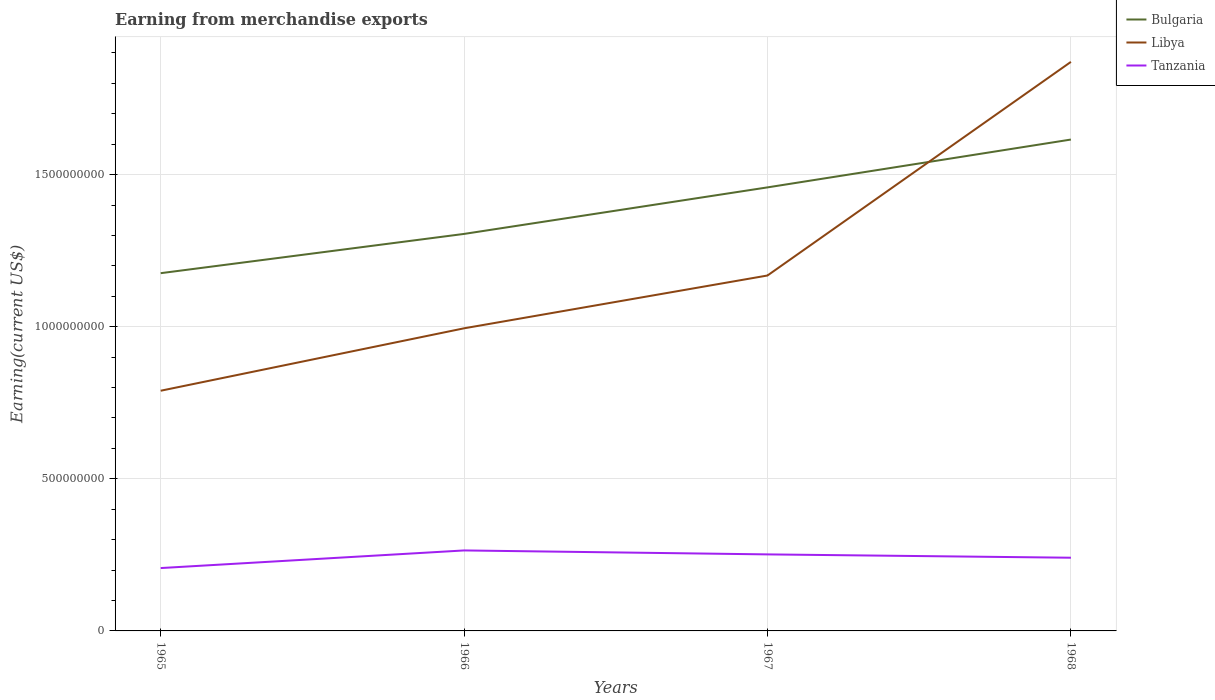Does the line corresponding to Bulgaria intersect with the line corresponding to Libya?
Provide a short and direct response. Yes. Across all years, what is the maximum amount earned from merchandise exports in Bulgaria?
Offer a terse response. 1.18e+09. In which year was the amount earned from merchandise exports in Tanzania maximum?
Make the answer very short. 1965. What is the total amount earned from merchandise exports in Libya in the graph?
Ensure brevity in your answer.  -1.74e+08. What is the difference between the highest and the second highest amount earned from merchandise exports in Bulgaria?
Give a very brief answer. 4.39e+08. How many years are there in the graph?
Provide a succinct answer. 4. Are the values on the major ticks of Y-axis written in scientific E-notation?
Ensure brevity in your answer.  No. Does the graph contain any zero values?
Keep it short and to the point. No. Where does the legend appear in the graph?
Keep it short and to the point. Top right. How many legend labels are there?
Offer a terse response. 3. What is the title of the graph?
Your answer should be compact. Earning from merchandise exports. Does "Vietnam" appear as one of the legend labels in the graph?
Offer a very short reply. No. What is the label or title of the Y-axis?
Provide a succinct answer. Earning(current US$). What is the Earning(current US$) in Bulgaria in 1965?
Make the answer very short. 1.18e+09. What is the Earning(current US$) of Libya in 1965?
Keep it short and to the point. 7.90e+08. What is the Earning(current US$) in Tanzania in 1965?
Give a very brief answer. 2.07e+08. What is the Earning(current US$) in Bulgaria in 1966?
Give a very brief answer. 1.31e+09. What is the Earning(current US$) in Libya in 1966?
Your response must be concise. 9.95e+08. What is the Earning(current US$) of Tanzania in 1966?
Keep it short and to the point. 2.65e+08. What is the Earning(current US$) in Bulgaria in 1967?
Your response must be concise. 1.46e+09. What is the Earning(current US$) of Libya in 1967?
Give a very brief answer. 1.17e+09. What is the Earning(current US$) of Tanzania in 1967?
Provide a short and direct response. 2.52e+08. What is the Earning(current US$) of Bulgaria in 1968?
Ensure brevity in your answer.  1.62e+09. What is the Earning(current US$) in Libya in 1968?
Provide a short and direct response. 1.87e+09. What is the Earning(current US$) of Tanzania in 1968?
Your answer should be very brief. 2.41e+08. Across all years, what is the maximum Earning(current US$) of Bulgaria?
Keep it short and to the point. 1.62e+09. Across all years, what is the maximum Earning(current US$) in Libya?
Your answer should be compact. 1.87e+09. Across all years, what is the maximum Earning(current US$) in Tanzania?
Keep it short and to the point. 2.65e+08. Across all years, what is the minimum Earning(current US$) in Bulgaria?
Your answer should be compact. 1.18e+09. Across all years, what is the minimum Earning(current US$) in Libya?
Your answer should be very brief. 7.90e+08. Across all years, what is the minimum Earning(current US$) in Tanzania?
Keep it short and to the point. 2.07e+08. What is the total Earning(current US$) in Bulgaria in the graph?
Offer a very short reply. 5.55e+09. What is the total Earning(current US$) in Libya in the graph?
Make the answer very short. 4.82e+09. What is the total Earning(current US$) in Tanzania in the graph?
Your response must be concise. 9.63e+08. What is the difference between the Earning(current US$) in Bulgaria in 1965 and that in 1966?
Offer a terse response. -1.29e+08. What is the difference between the Earning(current US$) of Libya in 1965 and that in 1966?
Provide a short and direct response. -2.05e+08. What is the difference between the Earning(current US$) in Tanzania in 1965 and that in 1966?
Provide a short and direct response. -5.80e+07. What is the difference between the Earning(current US$) of Bulgaria in 1965 and that in 1967?
Make the answer very short. -2.82e+08. What is the difference between the Earning(current US$) in Libya in 1965 and that in 1967?
Offer a terse response. -3.79e+08. What is the difference between the Earning(current US$) in Tanzania in 1965 and that in 1967?
Provide a succinct answer. -4.49e+07. What is the difference between the Earning(current US$) in Bulgaria in 1965 and that in 1968?
Your answer should be very brief. -4.39e+08. What is the difference between the Earning(current US$) in Libya in 1965 and that in 1968?
Give a very brief answer. -1.08e+09. What is the difference between the Earning(current US$) in Tanzania in 1965 and that in 1968?
Your response must be concise. -3.40e+07. What is the difference between the Earning(current US$) in Bulgaria in 1966 and that in 1967?
Your response must be concise. -1.53e+08. What is the difference between the Earning(current US$) in Libya in 1966 and that in 1967?
Keep it short and to the point. -1.74e+08. What is the difference between the Earning(current US$) of Tanzania in 1966 and that in 1967?
Offer a terse response. 1.30e+07. What is the difference between the Earning(current US$) of Bulgaria in 1966 and that in 1968?
Offer a terse response. -3.10e+08. What is the difference between the Earning(current US$) of Libya in 1966 and that in 1968?
Offer a very short reply. -8.76e+08. What is the difference between the Earning(current US$) in Tanzania in 1966 and that in 1968?
Provide a short and direct response. 2.39e+07. What is the difference between the Earning(current US$) of Bulgaria in 1967 and that in 1968?
Provide a short and direct response. -1.57e+08. What is the difference between the Earning(current US$) in Libya in 1967 and that in 1968?
Your response must be concise. -7.02e+08. What is the difference between the Earning(current US$) of Tanzania in 1967 and that in 1968?
Your response must be concise. 1.09e+07. What is the difference between the Earning(current US$) of Bulgaria in 1965 and the Earning(current US$) of Libya in 1966?
Your answer should be very brief. 1.81e+08. What is the difference between the Earning(current US$) of Bulgaria in 1965 and the Earning(current US$) of Tanzania in 1966?
Give a very brief answer. 9.11e+08. What is the difference between the Earning(current US$) in Libya in 1965 and the Earning(current US$) in Tanzania in 1966?
Your response must be concise. 5.25e+08. What is the difference between the Earning(current US$) in Bulgaria in 1965 and the Earning(current US$) in Libya in 1967?
Provide a short and direct response. 7.63e+06. What is the difference between the Earning(current US$) of Bulgaria in 1965 and the Earning(current US$) of Tanzania in 1967?
Make the answer very short. 9.25e+08. What is the difference between the Earning(current US$) of Libya in 1965 and the Earning(current US$) of Tanzania in 1967?
Offer a terse response. 5.38e+08. What is the difference between the Earning(current US$) of Bulgaria in 1965 and the Earning(current US$) of Libya in 1968?
Make the answer very short. -6.95e+08. What is the difference between the Earning(current US$) in Bulgaria in 1965 and the Earning(current US$) in Tanzania in 1968?
Offer a terse response. 9.35e+08. What is the difference between the Earning(current US$) in Libya in 1965 and the Earning(current US$) in Tanzania in 1968?
Offer a terse response. 5.49e+08. What is the difference between the Earning(current US$) in Bulgaria in 1966 and the Earning(current US$) in Libya in 1967?
Your answer should be very brief. 1.37e+08. What is the difference between the Earning(current US$) in Bulgaria in 1966 and the Earning(current US$) in Tanzania in 1967?
Keep it short and to the point. 1.05e+09. What is the difference between the Earning(current US$) in Libya in 1966 and the Earning(current US$) in Tanzania in 1967?
Keep it short and to the point. 7.43e+08. What is the difference between the Earning(current US$) in Bulgaria in 1966 and the Earning(current US$) in Libya in 1968?
Ensure brevity in your answer.  -5.66e+08. What is the difference between the Earning(current US$) in Bulgaria in 1966 and the Earning(current US$) in Tanzania in 1968?
Your response must be concise. 1.06e+09. What is the difference between the Earning(current US$) of Libya in 1966 and the Earning(current US$) of Tanzania in 1968?
Offer a terse response. 7.54e+08. What is the difference between the Earning(current US$) in Bulgaria in 1967 and the Earning(current US$) in Libya in 1968?
Give a very brief answer. -4.13e+08. What is the difference between the Earning(current US$) of Bulgaria in 1967 and the Earning(current US$) of Tanzania in 1968?
Provide a short and direct response. 1.22e+09. What is the difference between the Earning(current US$) in Libya in 1967 and the Earning(current US$) in Tanzania in 1968?
Provide a short and direct response. 9.28e+08. What is the average Earning(current US$) of Bulgaria per year?
Offer a very short reply. 1.39e+09. What is the average Earning(current US$) in Libya per year?
Provide a succinct answer. 1.21e+09. What is the average Earning(current US$) in Tanzania per year?
Provide a short and direct response. 2.41e+08. In the year 1965, what is the difference between the Earning(current US$) of Bulgaria and Earning(current US$) of Libya?
Offer a very short reply. 3.86e+08. In the year 1965, what is the difference between the Earning(current US$) of Bulgaria and Earning(current US$) of Tanzania?
Provide a short and direct response. 9.69e+08. In the year 1965, what is the difference between the Earning(current US$) in Libya and Earning(current US$) in Tanzania?
Your response must be concise. 5.83e+08. In the year 1966, what is the difference between the Earning(current US$) of Bulgaria and Earning(current US$) of Libya?
Keep it short and to the point. 3.10e+08. In the year 1966, what is the difference between the Earning(current US$) of Bulgaria and Earning(current US$) of Tanzania?
Your response must be concise. 1.04e+09. In the year 1966, what is the difference between the Earning(current US$) in Libya and Earning(current US$) in Tanzania?
Your answer should be very brief. 7.30e+08. In the year 1967, what is the difference between the Earning(current US$) in Bulgaria and Earning(current US$) in Libya?
Offer a very short reply. 2.90e+08. In the year 1967, what is the difference between the Earning(current US$) of Bulgaria and Earning(current US$) of Tanzania?
Offer a very short reply. 1.21e+09. In the year 1967, what is the difference between the Earning(current US$) in Libya and Earning(current US$) in Tanzania?
Make the answer very short. 9.17e+08. In the year 1968, what is the difference between the Earning(current US$) of Bulgaria and Earning(current US$) of Libya?
Provide a succinct answer. -2.55e+08. In the year 1968, what is the difference between the Earning(current US$) in Bulgaria and Earning(current US$) in Tanzania?
Offer a very short reply. 1.37e+09. In the year 1968, what is the difference between the Earning(current US$) in Libya and Earning(current US$) in Tanzania?
Offer a very short reply. 1.63e+09. What is the ratio of the Earning(current US$) in Bulgaria in 1965 to that in 1966?
Your answer should be very brief. 0.9. What is the ratio of the Earning(current US$) in Libya in 1965 to that in 1966?
Your answer should be compact. 0.79. What is the ratio of the Earning(current US$) of Tanzania in 1965 to that in 1966?
Offer a very short reply. 0.78. What is the ratio of the Earning(current US$) in Bulgaria in 1965 to that in 1967?
Provide a short and direct response. 0.81. What is the ratio of the Earning(current US$) of Libya in 1965 to that in 1967?
Offer a very short reply. 0.68. What is the ratio of the Earning(current US$) of Tanzania in 1965 to that in 1967?
Make the answer very short. 0.82. What is the ratio of the Earning(current US$) in Bulgaria in 1965 to that in 1968?
Ensure brevity in your answer.  0.73. What is the ratio of the Earning(current US$) of Libya in 1965 to that in 1968?
Provide a short and direct response. 0.42. What is the ratio of the Earning(current US$) of Tanzania in 1965 to that in 1968?
Your answer should be compact. 0.86. What is the ratio of the Earning(current US$) of Bulgaria in 1966 to that in 1967?
Your answer should be compact. 0.9. What is the ratio of the Earning(current US$) of Libya in 1966 to that in 1967?
Offer a very short reply. 0.85. What is the ratio of the Earning(current US$) of Tanzania in 1966 to that in 1967?
Provide a short and direct response. 1.05. What is the ratio of the Earning(current US$) of Bulgaria in 1966 to that in 1968?
Offer a very short reply. 0.81. What is the ratio of the Earning(current US$) of Libya in 1966 to that in 1968?
Your response must be concise. 0.53. What is the ratio of the Earning(current US$) of Tanzania in 1966 to that in 1968?
Your response must be concise. 1.1. What is the ratio of the Earning(current US$) of Bulgaria in 1967 to that in 1968?
Provide a short and direct response. 0.9. What is the ratio of the Earning(current US$) in Libya in 1967 to that in 1968?
Give a very brief answer. 0.62. What is the ratio of the Earning(current US$) of Tanzania in 1967 to that in 1968?
Offer a terse response. 1.05. What is the difference between the highest and the second highest Earning(current US$) in Bulgaria?
Make the answer very short. 1.57e+08. What is the difference between the highest and the second highest Earning(current US$) in Libya?
Your answer should be compact. 7.02e+08. What is the difference between the highest and the second highest Earning(current US$) of Tanzania?
Your response must be concise. 1.30e+07. What is the difference between the highest and the lowest Earning(current US$) in Bulgaria?
Ensure brevity in your answer.  4.39e+08. What is the difference between the highest and the lowest Earning(current US$) of Libya?
Keep it short and to the point. 1.08e+09. What is the difference between the highest and the lowest Earning(current US$) of Tanzania?
Keep it short and to the point. 5.80e+07. 